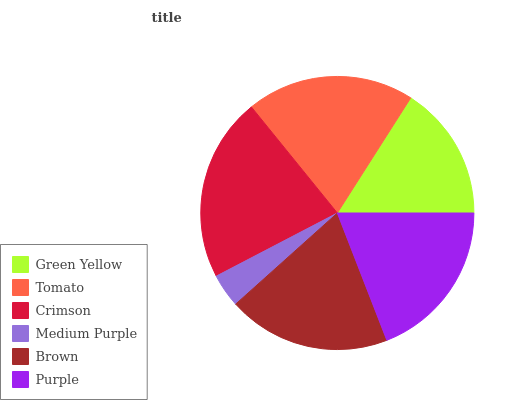Is Medium Purple the minimum?
Answer yes or no. Yes. Is Crimson the maximum?
Answer yes or no. Yes. Is Tomato the minimum?
Answer yes or no. No. Is Tomato the maximum?
Answer yes or no. No. Is Tomato greater than Green Yellow?
Answer yes or no. Yes. Is Green Yellow less than Tomato?
Answer yes or no. Yes. Is Green Yellow greater than Tomato?
Answer yes or no. No. Is Tomato less than Green Yellow?
Answer yes or no. No. Is Brown the high median?
Answer yes or no. Yes. Is Purple the low median?
Answer yes or no. Yes. Is Purple the high median?
Answer yes or no. No. Is Crimson the low median?
Answer yes or no. No. 